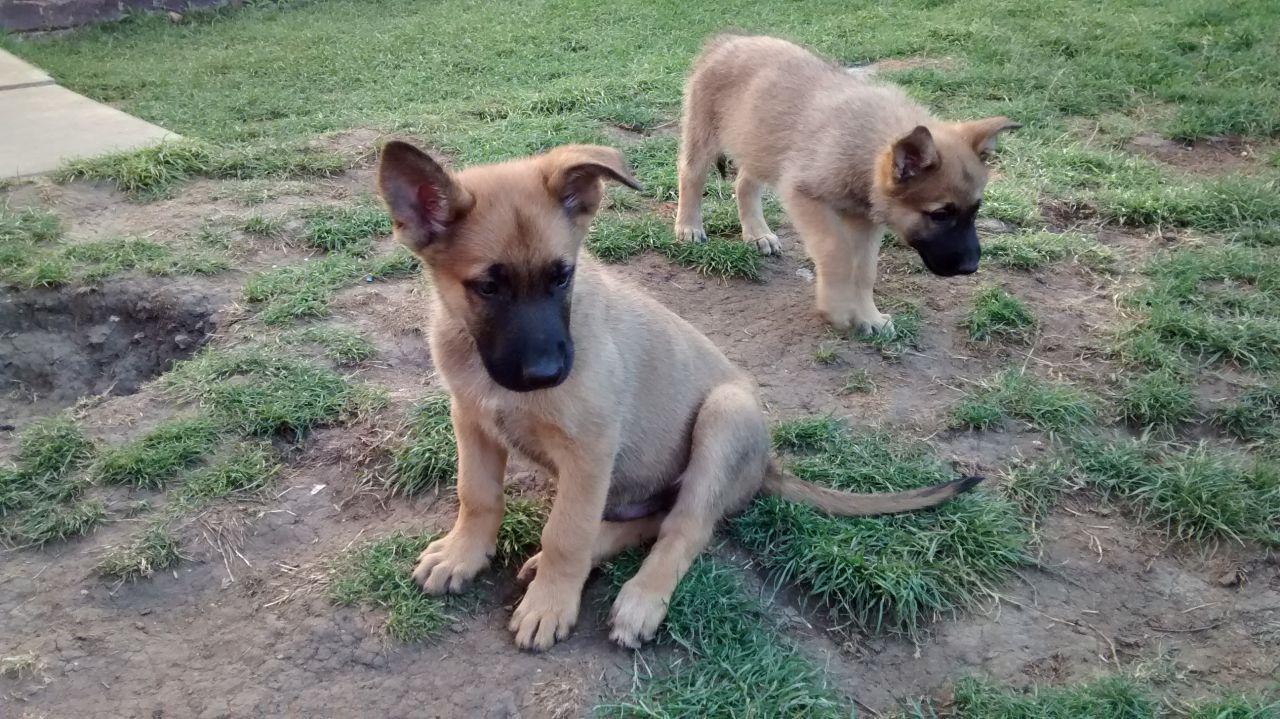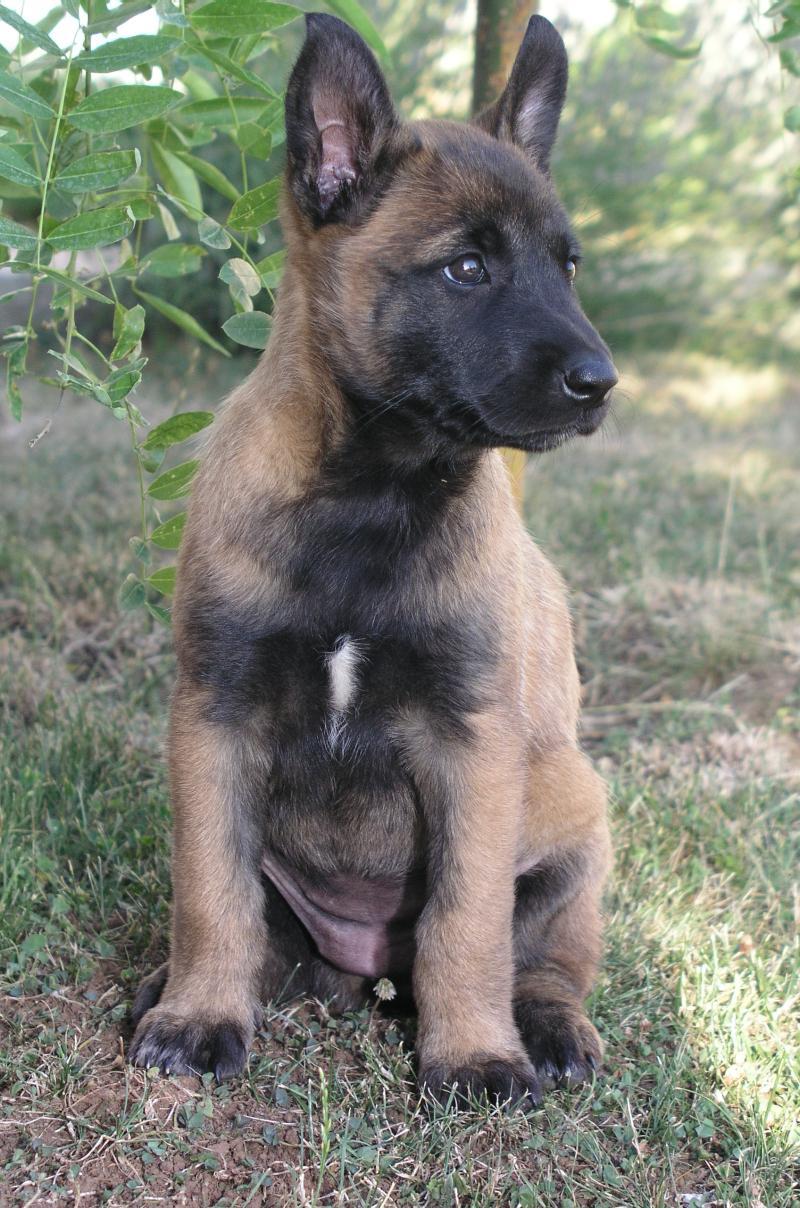The first image is the image on the left, the second image is the image on the right. Assess this claim about the two images: "The left image contains two dogs.". Correct or not? Answer yes or no. Yes. The first image is the image on the left, the second image is the image on the right. Examine the images to the left and right. Is the description "The righthand image contains exactly one dog, which is sitting upright with its body turned to the camera." accurate? Answer yes or no. Yes. 